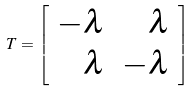<formula> <loc_0><loc_0><loc_500><loc_500>T = \left [ \begin{array} { r r } - \lambda & \lambda \\ \lambda & - \lambda \end{array} \right ]</formula> 